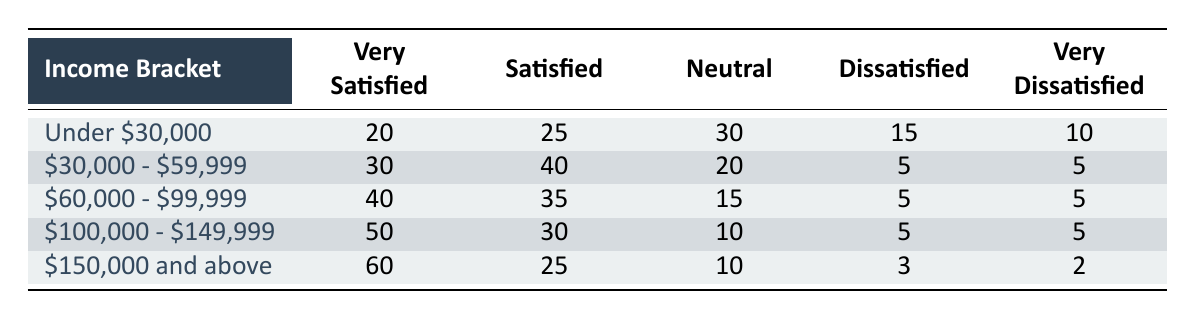What is the highest number of "very satisfied" customers in an income bracket? The highest number of "very satisfied" customers is in the income bracket "$150,000 and above," which has 60 customers.
Answer: 60 Which income bracket has the least number of "dissatisfied" customers? The income bracket "$150,000 and above" has the least number of dissatisfied customers, with only 3.
Answer: 3 What is the average number of "neutral" responses across all income brackets? To find the average, we sum the neutral responses: 30 + 20 + 15 + 10 + 10 = 85. There are 5 income brackets, so the average is 85/5 = 17.
Answer: 17 Is the statement "more than half of customers in the '$100,000 - $149,999' income bracket are very satisfied" true? In the '$100,000 - $149,999' bracket, 50 customers are very satisfied out of 100 total responses, which is exactly half, so the statement is false.
Answer: False What is the difference in the number of "very dissatisfied" customers between the lowest and highest income brackets? The lowest income bracket (Under $30,000) has 10 very dissatisfied customers and the highest (over $150,000) has 2. The difference is 10 - 2 = 8.
Answer: 8 How many customers in the "$30,000 - $59,999" bracket are either satisfied or very satisfied? Adding the satisfied (40) and very satisfied (30) customers gives us a total of 70 customers satisfied or very satisfied in this income bracket.
Answer: 70 Which income bracket has the most "satisfied" customers? The income bracket "$30,000 - $59,999" has the most satisfied customers, totaling 40.
Answer: 40 How many customers in the lowest income bracket are either neutral or dissatisfied? There are 30 neutral and 15 dissatisfied customers in the under $30,000 bracket. Adding them gives us 30 + 15 = 45 customers.
Answer: 45 